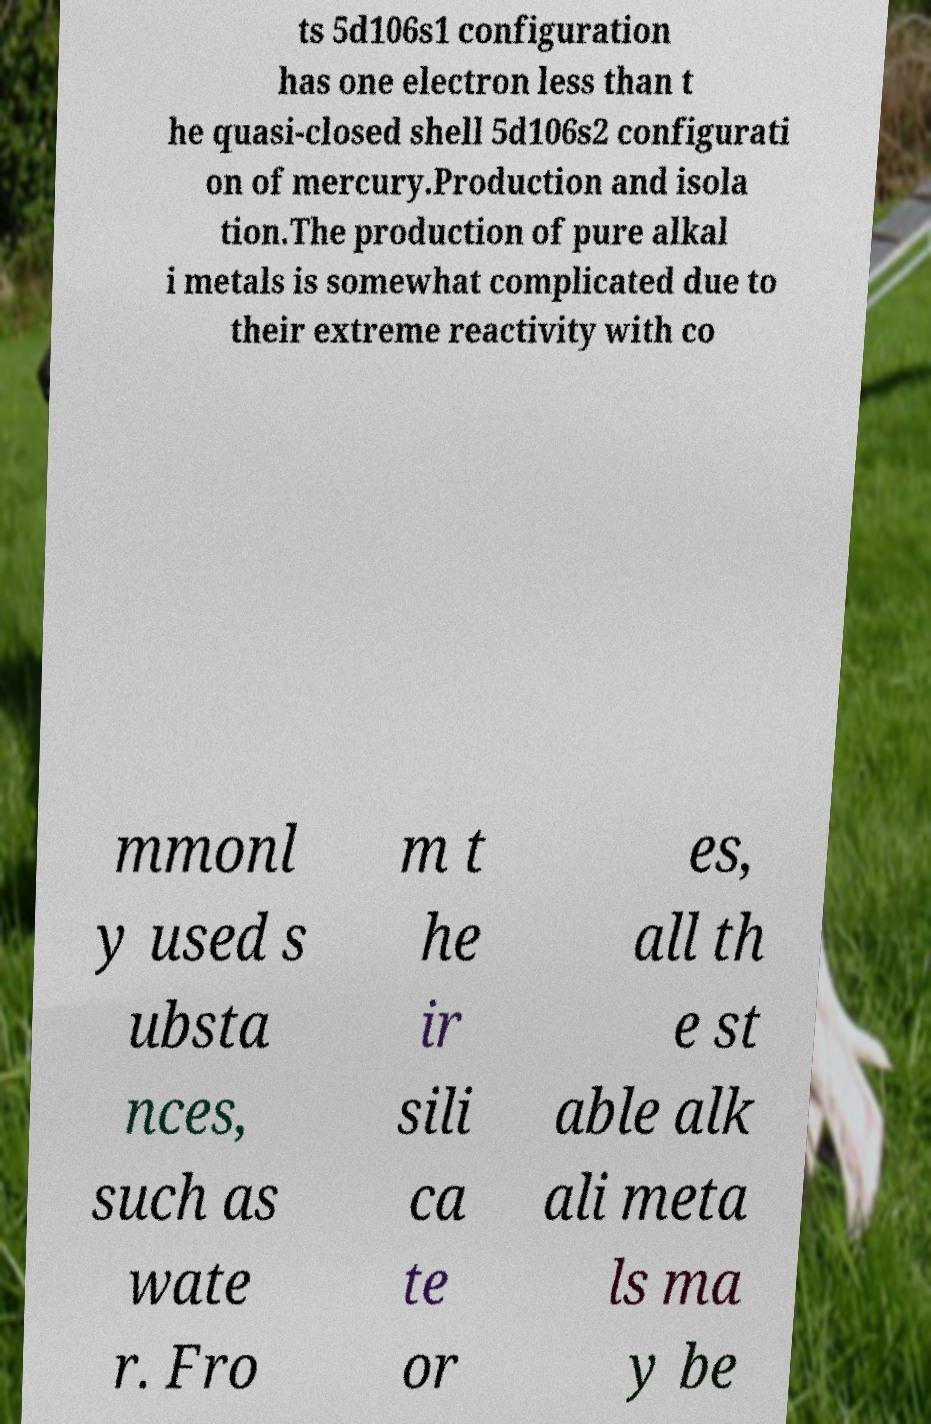Could you extract and type out the text from this image? ts 5d106s1 configuration has one electron less than t he quasi-closed shell 5d106s2 configurati on of mercury.Production and isola tion.The production of pure alkal i metals is somewhat complicated due to their extreme reactivity with co mmonl y used s ubsta nces, such as wate r. Fro m t he ir sili ca te or es, all th e st able alk ali meta ls ma y be 